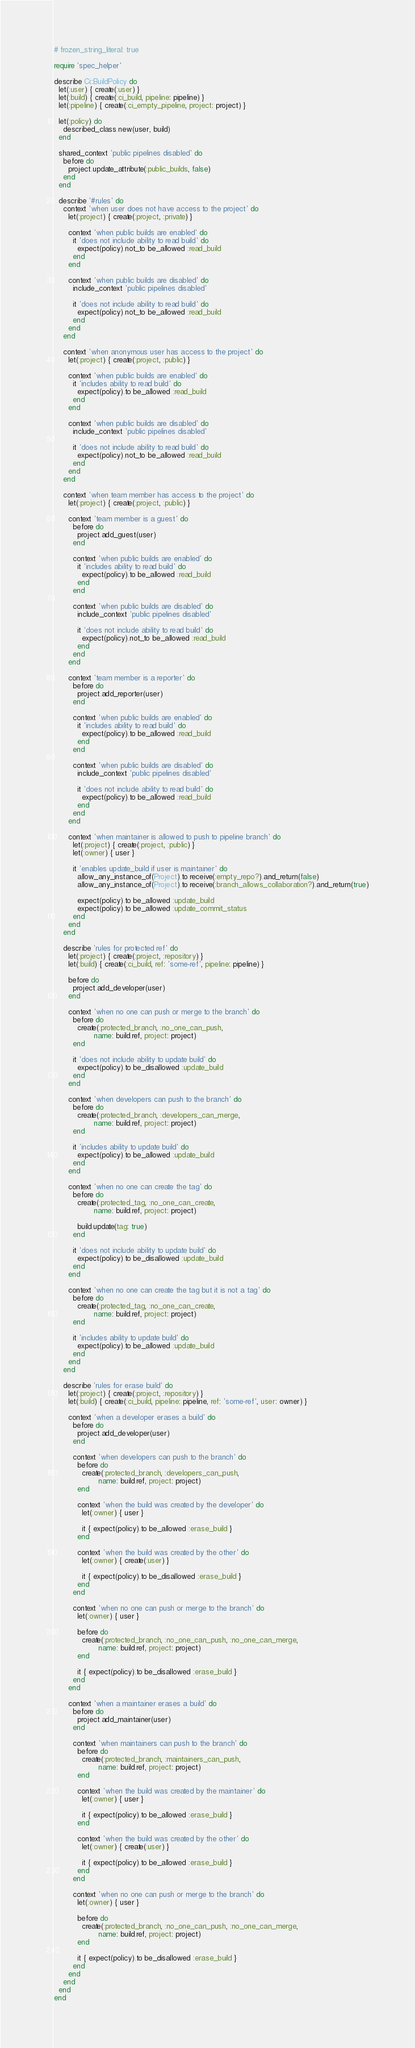<code> <loc_0><loc_0><loc_500><loc_500><_Ruby_># frozen_string_literal: true

require 'spec_helper'

describe Ci::BuildPolicy do
  let(:user) { create(:user) }
  let(:build) { create(:ci_build, pipeline: pipeline) }
  let(:pipeline) { create(:ci_empty_pipeline, project: project) }

  let(:policy) do
    described_class.new(user, build)
  end

  shared_context 'public pipelines disabled' do
    before do
      project.update_attribute(:public_builds, false)
    end
  end

  describe '#rules' do
    context 'when user does not have access to the project' do
      let(:project) { create(:project, :private) }

      context 'when public builds are enabled' do
        it 'does not include ability to read build' do
          expect(policy).not_to be_allowed :read_build
        end
      end

      context 'when public builds are disabled' do
        include_context 'public pipelines disabled'

        it 'does not include ability to read build' do
          expect(policy).not_to be_allowed :read_build
        end
      end
    end

    context 'when anonymous user has access to the project' do
      let(:project) { create(:project, :public) }

      context 'when public builds are enabled' do
        it 'includes ability to read build' do
          expect(policy).to be_allowed :read_build
        end
      end

      context 'when public builds are disabled' do
        include_context 'public pipelines disabled'

        it 'does not include ability to read build' do
          expect(policy).not_to be_allowed :read_build
        end
      end
    end

    context 'when team member has access to the project' do
      let(:project) { create(:project, :public) }

      context 'team member is a guest' do
        before do
          project.add_guest(user)
        end

        context 'when public builds are enabled' do
          it 'includes ability to read build' do
            expect(policy).to be_allowed :read_build
          end
        end

        context 'when public builds are disabled' do
          include_context 'public pipelines disabled'

          it 'does not include ability to read build' do
            expect(policy).not_to be_allowed :read_build
          end
        end
      end

      context 'team member is a reporter' do
        before do
          project.add_reporter(user)
        end

        context 'when public builds are enabled' do
          it 'includes ability to read build' do
            expect(policy).to be_allowed :read_build
          end
        end

        context 'when public builds are disabled' do
          include_context 'public pipelines disabled'

          it 'does not include ability to read build' do
            expect(policy).to be_allowed :read_build
          end
        end
      end

      context 'when maintainer is allowed to push to pipeline branch' do
        let(:project) { create(:project, :public) }
        let(:owner) { user }

        it 'enables update_build if user is maintainer' do
          allow_any_instance_of(Project).to receive(:empty_repo?).and_return(false)
          allow_any_instance_of(Project).to receive(:branch_allows_collaboration?).and_return(true)

          expect(policy).to be_allowed :update_build
          expect(policy).to be_allowed :update_commit_status
        end
      end
    end

    describe 'rules for protected ref' do
      let(:project) { create(:project, :repository) }
      let(:build) { create(:ci_build, ref: 'some-ref', pipeline: pipeline) }

      before do
        project.add_developer(user)
      end

      context 'when no one can push or merge to the branch' do
        before do
          create(:protected_branch, :no_one_can_push,
                 name: build.ref, project: project)
        end

        it 'does not include ability to update build' do
          expect(policy).to be_disallowed :update_build
        end
      end

      context 'when developers can push to the branch' do
        before do
          create(:protected_branch, :developers_can_merge,
                 name: build.ref, project: project)
        end

        it 'includes ability to update build' do
          expect(policy).to be_allowed :update_build
        end
      end

      context 'when no one can create the tag' do
        before do
          create(:protected_tag, :no_one_can_create,
                 name: build.ref, project: project)

          build.update(tag: true)
        end

        it 'does not include ability to update build' do
          expect(policy).to be_disallowed :update_build
        end
      end

      context 'when no one can create the tag but it is not a tag' do
        before do
          create(:protected_tag, :no_one_can_create,
                 name: build.ref, project: project)
        end

        it 'includes ability to update build' do
          expect(policy).to be_allowed :update_build
        end
      end
    end

    describe 'rules for erase build' do
      let(:project) { create(:project, :repository) }
      let(:build) { create(:ci_build, pipeline: pipeline, ref: 'some-ref', user: owner) }

      context 'when a developer erases a build' do
        before do
          project.add_developer(user)
        end

        context 'when developers can push to the branch' do
          before do
            create(:protected_branch, :developers_can_push,
                   name: build.ref, project: project)
          end

          context 'when the build was created by the developer' do
            let(:owner) { user }

            it { expect(policy).to be_allowed :erase_build }
          end

          context 'when the build was created by the other' do
            let(:owner) { create(:user) }

            it { expect(policy).to be_disallowed :erase_build }
          end
        end

        context 'when no one can push or merge to the branch' do
          let(:owner) { user }

          before do
            create(:protected_branch, :no_one_can_push, :no_one_can_merge,
                   name: build.ref, project: project)
          end

          it { expect(policy).to be_disallowed :erase_build }
        end
      end

      context 'when a maintainer erases a build' do
        before do
          project.add_maintainer(user)
        end

        context 'when maintainers can push to the branch' do
          before do
            create(:protected_branch, :maintainers_can_push,
                   name: build.ref, project: project)
          end

          context 'when the build was created by the maintainer' do
            let(:owner) { user }

            it { expect(policy).to be_allowed :erase_build }
          end

          context 'when the build was created by the other' do
            let(:owner) { create(:user) }

            it { expect(policy).to be_allowed :erase_build }
          end
        end

        context 'when no one can push or merge to the branch' do
          let(:owner) { user }

          before do
            create(:protected_branch, :no_one_can_push, :no_one_can_merge,
                   name: build.ref, project: project)
          end

          it { expect(policy).to be_disallowed :erase_build }
        end
      end
    end
  end
end
</code> 